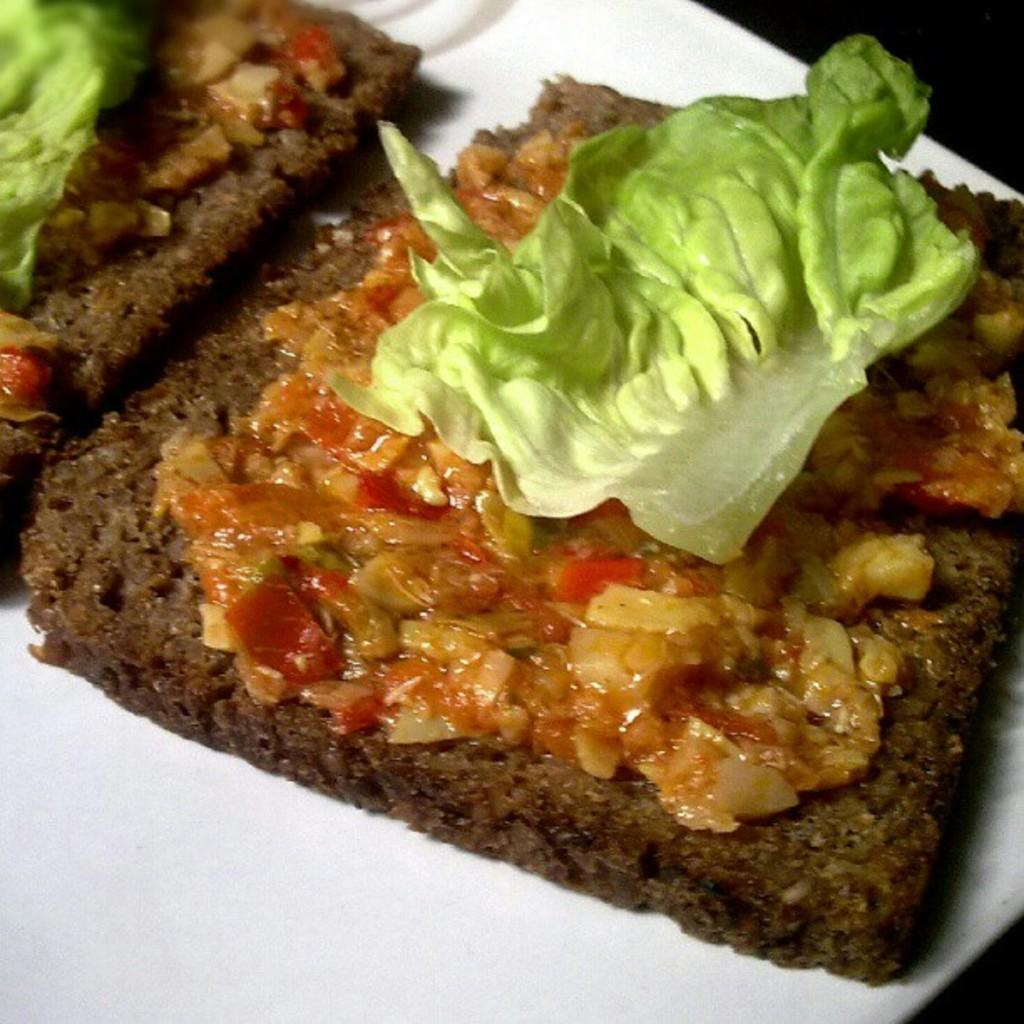What is placed on the plate in the image? There is a plate with food items in the image. Can you describe the food items on the plate? Unfortunately, the specific food items cannot be determined from the given facts. Is there any utensil or accompaniment visible with the plate? The provided facts do not mention any utensils or accompaniments. Where is the playground located in the image? There is no playground present in the image; it features a plate with food items. What type of toys can be seen on the plate? There are no toys present on the plate; it contains food items. 